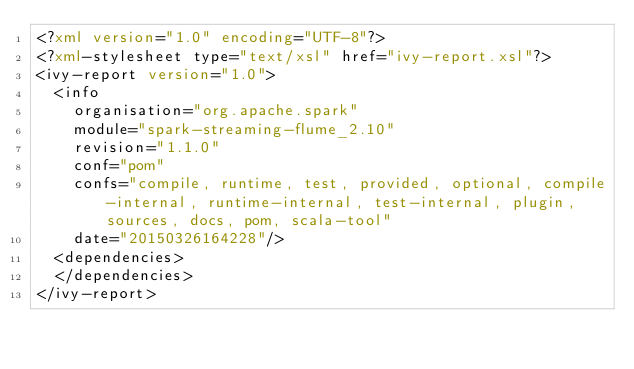<code> <loc_0><loc_0><loc_500><loc_500><_XML_><?xml version="1.0" encoding="UTF-8"?>
<?xml-stylesheet type="text/xsl" href="ivy-report.xsl"?>
<ivy-report version="1.0">
	<info
		organisation="org.apache.spark"
		module="spark-streaming-flume_2.10"
		revision="1.1.0"
		conf="pom"
		confs="compile, runtime, test, provided, optional, compile-internal, runtime-internal, test-internal, plugin, sources, docs, pom, scala-tool"
		date="20150326164228"/>
	<dependencies>
	</dependencies>
</ivy-report>
</code> 